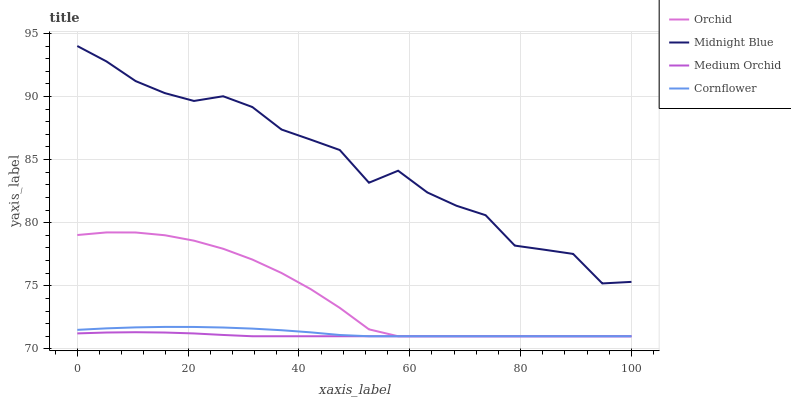Does Medium Orchid have the minimum area under the curve?
Answer yes or no. Yes. Does Midnight Blue have the maximum area under the curve?
Answer yes or no. Yes. Does Midnight Blue have the minimum area under the curve?
Answer yes or no. No. Does Medium Orchid have the maximum area under the curve?
Answer yes or no. No. Is Medium Orchid the smoothest?
Answer yes or no. Yes. Is Midnight Blue the roughest?
Answer yes or no. Yes. Is Midnight Blue the smoothest?
Answer yes or no. No. Is Medium Orchid the roughest?
Answer yes or no. No. Does Midnight Blue have the lowest value?
Answer yes or no. No. Does Medium Orchid have the highest value?
Answer yes or no. No. Is Cornflower less than Midnight Blue?
Answer yes or no. Yes. Is Midnight Blue greater than Orchid?
Answer yes or no. Yes. Does Cornflower intersect Midnight Blue?
Answer yes or no. No. 